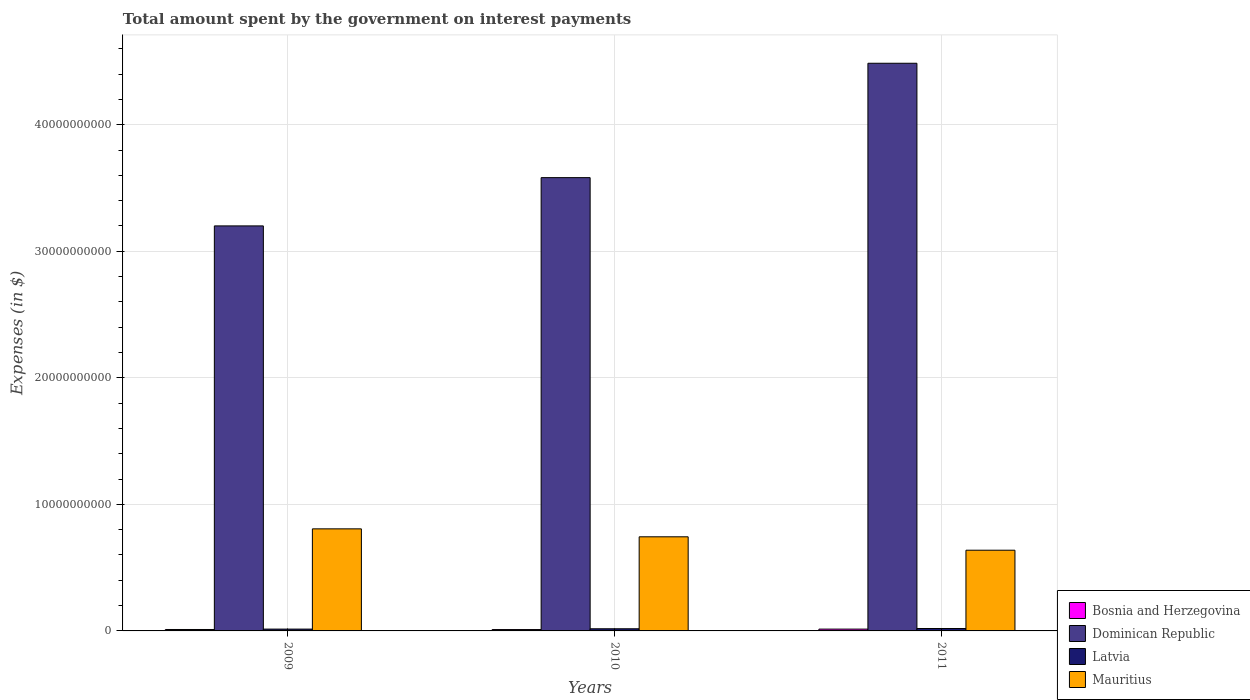How many groups of bars are there?
Your response must be concise. 3. Are the number of bars on each tick of the X-axis equal?
Your response must be concise. Yes. In how many cases, is the number of bars for a given year not equal to the number of legend labels?
Your answer should be compact. 0. What is the amount spent on interest payments by the government in Bosnia and Herzegovina in 2009?
Provide a succinct answer. 1.13e+08. Across all years, what is the maximum amount spent on interest payments by the government in Mauritius?
Give a very brief answer. 8.07e+09. Across all years, what is the minimum amount spent on interest payments by the government in Latvia?
Your answer should be compact. 1.44e+08. In which year was the amount spent on interest payments by the government in Bosnia and Herzegovina maximum?
Offer a terse response. 2011. In which year was the amount spent on interest payments by the government in Dominican Republic minimum?
Keep it short and to the point. 2009. What is the total amount spent on interest payments by the government in Mauritius in the graph?
Provide a succinct answer. 2.19e+1. What is the difference between the amount spent on interest payments by the government in Latvia in 2009 and that in 2010?
Make the answer very short. -2.62e+07. What is the difference between the amount spent on interest payments by the government in Dominican Republic in 2011 and the amount spent on interest payments by the government in Bosnia and Herzegovina in 2010?
Give a very brief answer. 4.48e+1. What is the average amount spent on interest payments by the government in Latvia per year?
Your answer should be very brief. 1.68e+08. In the year 2009, what is the difference between the amount spent on interest payments by the government in Latvia and amount spent on interest payments by the government in Dominican Republic?
Keep it short and to the point. -3.19e+1. In how many years, is the amount spent on interest payments by the government in Bosnia and Herzegovina greater than 10000000000 $?
Offer a terse response. 0. What is the ratio of the amount spent on interest payments by the government in Bosnia and Herzegovina in 2010 to that in 2011?
Your answer should be compact. 0.75. Is the difference between the amount spent on interest payments by the government in Latvia in 2010 and 2011 greater than the difference between the amount spent on interest payments by the government in Dominican Republic in 2010 and 2011?
Give a very brief answer. Yes. What is the difference between the highest and the second highest amount spent on interest payments by the government in Bosnia and Herzegovina?
Offer a very short reply. 3.12e+07. What is the difference between the highest and the lowest amount spent on interest payments by the government in Bosnia and Herzegovina?
Your response must be concise. 3.56e+07. Is it the case that in every year, the sum of the amount spent on interest payments by the government in Dominican Republic and amount spent on interest payments by the government in Mauritius is greater than the sum of amount spent on interest payments by the government in Bosnia and Herzegovina and amount spent on interest payments by the government in Latvia?
Provide a short and direct response. No. What does the 4th bar from the left in 2011 represents?
Your answer should be compact. Mauritius. What does the 2nd bar from the right in 2009 represents?
Provide a succinct answer. Latvia. Is it the case that in every year, the sum of the amount spent on interest payments by the government in Mauritius and amount spent on interest payments by the government in Latvia is greater than the amount spent on interest payments by the government in Bosnia and Herzegovina?
Your response must be concise. Yes. How many bars are there?
Keep it short and to the point. 12. Are all the bars in the graph horizontal?
Offer a terse response. No. How many years are there in the graph?
Ensure brevity in your answer.  3. What is the difference between two consecutive major ticks on the Y-axis?
Ensure brevity in your answer.  1.00e+1. Are the values on the major ticks of Y-axis written in scientific E-notation?
Provide a succinct answer. No. Does the graph contain grids?
Provide a succinct answer. Yes. Where does the legend appear in the graph?
Ensure brevity in your answer.  Bottom right. How are the legend labels stacked?
Offer a very short reply. Vertical. What is the title of the graph?
Your answer should be compact. Total amount spent by the government on interest payments. What is the label or title of the X-axis?
Offer a very short reply. Years. What is the label or title of the Y-axis?
Give a very brief answer. Expenses (in $). What is the Expenses (in $) of Bosnia and Herzegovina in 2009?
Give a very brief answer. 1.13e+08. What is the Expenses (in $) in Dominican Republic in 2009?
Your response must be concise. 3.20e+1. What is the Expenses (in $) of Latvia in 2009?
Ensure brevity in your answer.  1.44e+08. What is the Expenses (in $) in Mauritius in 2009?
Provide a short and direct response. 8.07e+09. What is the Expenses (in $) of Bosnia and Herzegovina in 2010?
Ensure brevity in your answer.  1.08e+08. What is the Expenses (in $) in Dominican Republic in 2010?
Give a very brief answer. 3.58e+1. What is the Expenses (in $) of Latvia in 2010?
Your answer should be compact. 1.70e+08. What is the Expenses (in $) of Mauritius in 2010?
Offer a terse response. 7.44e+09. What is the Expenses (in $) of Bosnia and Herzegovina in 2011?
Provide a succinct answer. 1.44e+08. What is the Expenses (in $) of Dominican Republic in 2011?
Give a very brief answer. 4.49e+1. What is the Expenses (in $) of Latvia in 2011?
Ensure brevity in your answer.  1.91e+08. What is the Expenses (in $) in Mauritius in 2011?
Your answer should be very brief. 6.38e+09. Across all years, what is the maximum Expenses (in $) of Bosnia and Herzegovina?
Provide a succinct answer. 1.44e+08. Across all years, what is the maximum Expenses (in $) of Dominican Republic?
Keep it short and to the point. 4.49e+1. Across all years, what is the maximum Expenses (in $) in Latvia?
Make the answer very short. 1.91e+08. Across all years, what is the maximum Expenses (in $) of Mauritius?
Ensure brevity in your answer.  8.07e+09. Across all years, what is the minimum Expenses (in $) of Bosnia and Herzegovina?
Offer a terse response. 1.08e+08. Across all years, what is the minimum Expenses (in $) of Dominican Republic?
Your answer should be very brief. 3.20e+1. Across all years, what is the minimum Expenses (in $) in Latvia?
Ensure brevity in your answer.  1.44e+08. Across all years, what is the minimum Expenses (in $) in Mauritius?
Offer a very short reply. 6.38e+09. What is the total Expenses (in $) in Bosnia and Herzegovina in the graph?
Provide a succinct answer. 3.64e+08. What is the total Expenses (in $) in Dominican Republic in the graph?
Make the answer very short. 1.13e+11. What is the total Expenses (in $) in Latvia in the graph?
Your response must be concise. 5.05e+08. What is the total Expenses (in $) in Mauritius in the graph?
Give a very brief answer. 2.19e+1. What is the difference between the Expenses (in $) in Bosnia and Herzegovina in 2009 and that in 2010?
Provide a short and direct response. 4.41e+06. What is the difference between the Expenses (in $) of Dominican Republic in 2009 and that in 2010?
Keep it short and to the point. -3.81e+09. What is the difference between the Expenses (in $) of Latvia in 2009 and that in 2010?
Keep it short and to the point. -2.62e+07. What is the difference between the Expenses (in $) of Mauritius in 2009 and that in 2010?
Offer a terse response. 6.28e+08. What is the difference between the Expenses (in $) in Bosnia and Herzegovina in 2009 and that in 2011?
Ensure brevity in your answer.  -3.12e+07. What is the difference between the Expenses (in $) of Dominican Republic in 2009 and that in 2011?
Ensure brevity in your answer.  -1.29e+1. What is the difference between the Expenses (in $) in Latvia in 2009 and that in 2011?
Your answer should be very brief. -4.69e+07. What is the difference between the Expenses (in $) of Mauritius in 2009 and that in 2011?
Your answer should be very brief. 1.69e+09. What is the difference between the Expenses (in $) of Bosnia and Herzegovina in 2010 and that in 2011?
Keep it short and to the point. -3.56e+07. What is the difference between the Expenses (in $) in Dominican Republic in 2010 and that in 2011?
Provide a short and direct response. -9.04e+09. What is the difference between the Expenses (in $) of Latvia in 2010 and that in 2011?
Provide a short and direct response. -2.07e+07. What is the difference between the Expenses (in $) in Mauritius in 2010 and that in 2011?
Make the answer very short. 1.06e+09. What is the difference between the Expenses (in $) of Bosnia and Herzegovina in 2009 and the Expenses (in $) of Dominican Republic in 2010?
Your answer should be compact. -3.57e+1. What is the difference between the Expenses (in $) in Bosnia and Herzegovina in 2009 and the Expenses (in $) in Latvia in 2010?
Provide a short and direct response. -5.77e+07. What is the difference between the Expenses (in $) in Bosnia and Herzegovina in 2009 and the Expenses (in $) in Mauritius in 2010?
Provide a succinct answer. -7.33e+09. What is the difference between the Expenses (in $) in Dominican Republic in 2009 and the Expenses (in $) in Latvia in 2010?
Offer a very short reply. 3.18e+1. What is the difference between the Expenses (in $) of Dominican Republic in 2009 and the Expenses (in $) of Mauritius in 2010?
Ensure brevity in your answer.  2.46e+1. What is the difference between the Expenses (in $) in Latvia in 2009 and the Expenses (in $) in Mauritius in 2010?
Offer a very short reply. -7.29e+09. What is the difference between the Expenses (in $) of Bosnia and Herzegovina in 2009 and the Expenses (in $) of Dominican Republic in 2011?
Ensure brevity in your answer.  -4.47e+1. What is the difference between the Expenses (in $) in Bosnia and Herzegovina in 2009 and the Expenses (in $) in Latvia in 2011?
Provide a succinct answer. -7.84e+07. What is the difference between the Expenses (in $) of Bosnia and Herzegovina in 2009 and the Expenses (in $) of Mauritius in 2011?
Provide a succinct answer. -6.26e+09. What is the difference between the Expenses (in $) of Dominican Republic in 2009 and the Expenses (in $) of Latvia in 2011?
Offer a very short reply. 3.18e+1. What is the difference between the Expenses (in $) in Dominican Republic in 2009 and the Expenses (in $) in Mauritius in 2011?
Give a very brief answer. 2.56e+1. What is the difference between the Expenses (in $) in Latvia in 2009 and the Expenses (in $) in Mauritius in 2011?
Offer a very short reply. -6.23e+09. What is the difference between the Expenses (in $) of Bosnia and Herzegovina in 2010 and the Expenses (in $) of Dominican Republic in 2011?
Provide a short and direct response. -4.48e+1. What is the difference between the Expenses (in $) of Bosnia and Herzegovina in 2010 and the Expenses (in $) of Latvia in 2011?
Provide a short and direct response. -8.28e+07. What is the difference between the Expenses (in $) in Bosnia and Herzegovina in 2010 and the Expenses (in $) in Mauritius in 2011?
Make the answer very short. -6.27e+09. What is the difference between the Expenses (in $) of Dominican Republic in 2010 and the Expenses (in $) of Latvia in 2011?
Provide a succinct answer. 3.56e+1. What is the difference between the Expenses (in $) in Dominican Republic in 2010 and the Expenses (in $) in Mauritius in 2011?
Give a very brief answer. 2.94e+1. What is the difference between the Expenses (in $) of Latvia in 2010 and the Expenses (in $) of Mauritius in 2011?
Make the answer very short. -6.21e+09. What is the average Expenses (in $) of Bosnia and Herzegovina per year?
Make the answer very short. 1.21e+08. What is the average Expenses (in $) of Dominican Republic per year?
Keep it short and to the point. 3.76e+1. What is the average Expenses (in $) of Latvia per year?
Your response must be concise. 1.68e+08. What is the average Expenses (in $) of Mauritius per year?
Offer a very short reply. 7.29e+09. In the year 2009, what is the difference between the Expenses (in $) in Bosnia and Herzegovina and Expenses (in $) in Dominican Republic?
Give a very brief answer. -3.19e+1. In the year 2009, what is the difference between the Expenses (in $) in Bosnia and Herzegovina and Expenses (in $) in Latvia?
Make the answer very short. -3.15e+07. In the year 2009, what is the difference between the Expenses (in $) in Bosnia and Herzegovina and Expenses (in $) in Mauritius?
Keep it short and to the point. -7.95e+09. In the year 2009, what is the difference between the Expenses (in $) in Dominican Republic and Expenses (in $) in Latvia?
Your answer should be very brief. 3.19e+1. In the year 2009, what is the difference between the Expenses (in $) of Dominican Republic and Expenses (in $) of Mauritius?
Offer a very short reply. 2.39e+1. In the year 2009, what is the difference between the Expenses (in $) of Latvia and Expenses (in $) of Mauritius?
Keep it short and to the point. -7.92e+09. In the year 2010, what is the difference between the Expenses (in $) of Bosnia and Herzegovina and Expenses (in $) of Dominican Republic?
Your answer should be compact. -3.57e+1. In the year 2010, what is the difference between the Expenses (in $) of Bosnia and Herzegovina and Expenses (in $) of Latvia?
Ensure brevity in your answer.  -6.21e+07. In the year 2010, what is the difference between the Expenses (in $) in Bosnia and Herzegovina and Expenses (in $) in Mauritius?
Provide a succinct answer. -7.33e+09. In the year 2010, what is the difference between the Expenses (in $) of Dominican Republic and Expenses (in $) of Latvia?
Offer a very short reply. 3.57e+1. In the year 2010, what is the difference between the Expenses (in $) of Dominican Republic and Expenses (in $) of Mauritius?
Ensure brevity in your answer.  2.84e+1. In the year 2010, what is the difference between the Expenses (in $) of Latvia and Expenses (in $) of Mauritius?
Make the answer very short. -7.27e+09. In the year 2011, what is the difference between the Expenses (in $) of Bosnia and Herzegovina and Expenses (in $) of Dominican Republic?
Provide a succinct answer. -4.47e+1. In the year 2011, what is the difference between the Expenses (in $) of Bosnia and Herzegovina and Expenses (in $) of Latvia?
Make the answer very short. -4.72e+07. In the year 2011, what is the difference between the Expenses (in $) in Bosnia and Herzegovina and Expenses (in $) in Mauritius?
Offer a very short reply. -6.23e+09. In the year 2011, what is the difference between the Expenses (in $) of Dominican Republic and Expenses (in $) of Latvia?
Make the answer very short. 4.47e+1. In the year 2011, what is the difference between the Expenses (in $) of Dominican Republic and Expenses (in $) of Mauritius?
Provide a short and direct response. 3.85e+1. In the year 2011, what is the difference between the Expenses (in $) of Latvia and Expenses (in $) of Mauritius?
Your answer should be very brief. -6.19e+09. What is the ratio of the Expenses (in $) in Bosnia and Herzegovina in 2009 to that in 2010?
Keep it short and to the point. 1.04. What is the ratio of the Expenses (in $) of Dominican Republic in 2009 to that in 2010?
Provide a succinct answer. 0.89. What is the ratio of the Expenses (in $) in Latvia in 2009 to that in 2010?
Provide a succinct answer. 0.85. What is the ratio of the Expenses (in $) of Mauritius in 2009 to that in 2010?
Keep it short and to the point. 1.08. What is the ratio of the Expenses (in $) in Bosnia and Herzegovina in 2009 to that in 2011?
Give a very brief answer. 0.78. What is the ratio of the Expenses (in $) in Dominican Republic in 2009 to that in 2011?
Your answer should be compact. 0.71. What is the ratio of the Expenses (in $) in Latvia in 2009 to that in 2011?
Offer a terse response. 0.75. What is the ratio of the Expenses (in $) of Mauritius in 2009 to that in 2011?
Provide a succinct answer. 1.26. What is the ratio of the Expenses (in $) of Bosnia and Herzegovina in 2010 to that in 2011?
Give a very brief answer. 0.75. What is the ratio of the Expenses (in $) of Dominican Republic in 2010 to that in 2011?
Your response must be concise. 0.8. What is the ratio of the Expenses (in $) of Latvia in 2010 to that in 2011?
Keep it short and to the point. 0.89. What is the ratio of the Expenses (in $) in Mauritius in 2010 to that in 2011?
Your response must be concise. 1.17. What is the difference between the highest and the second highest Expenses (in $) in Bosnia and Herzegovina?
Ensure brevity in your answer.  3.12e+07. What is the difference between the highest and the second highest Expenses (in $) in Dominican Republic?
Your response must be concise. 9.04e+09. What is the difference between the highest and the second highest Expenses (in $) of Latvia?
Offer a terse response. 2.07e+07. What is the difference between the highest and the second highest Expenses (in $) in Mauritius?
Your answer should be compact. 6.28e+08. What is the difference between the highest and the lowest Expenses (in $) in Bosnia and Herzegovina?
Give a very brief answer. 3.56e+07. What is the difference between the highest and the lowest Expenses (in $) of Dominican Republic?
Your answer should be very brief. 1.29e+1. What is the difference between the highest and the lowest Expenses (in $) in Latvia?
Provide a short and direct response. 4.69e+07. What is the difference between the highest and the lowest Expenses (in $) of Mauritius?
Make the answer very short. 1.69e+09. 